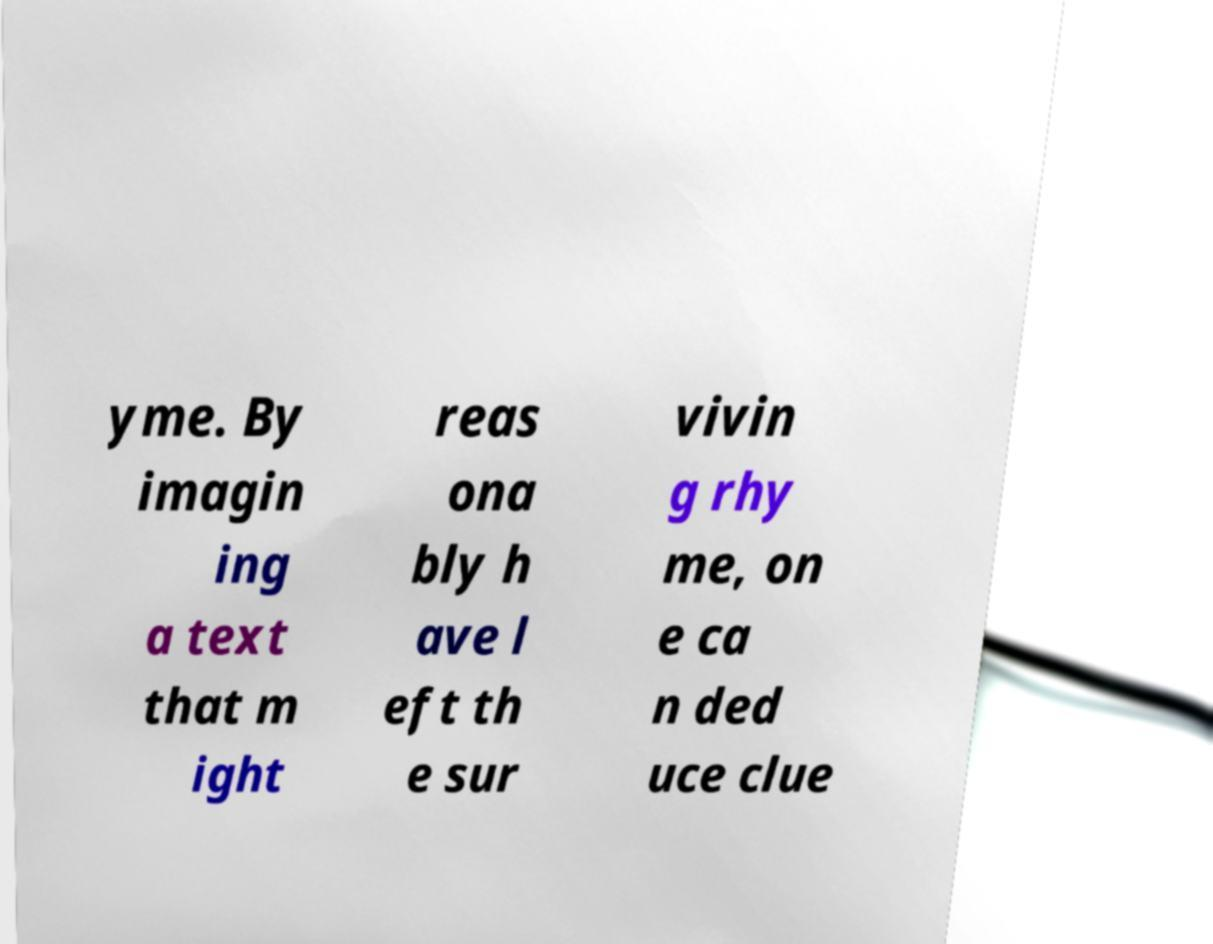What messages or text are displayed in this image? I need them in a readable, typed format. yme. By imagin ing a text that m ight reas ona bly h ave l eft th e sur vivin g rhy me, on e ca n ded uce clue 